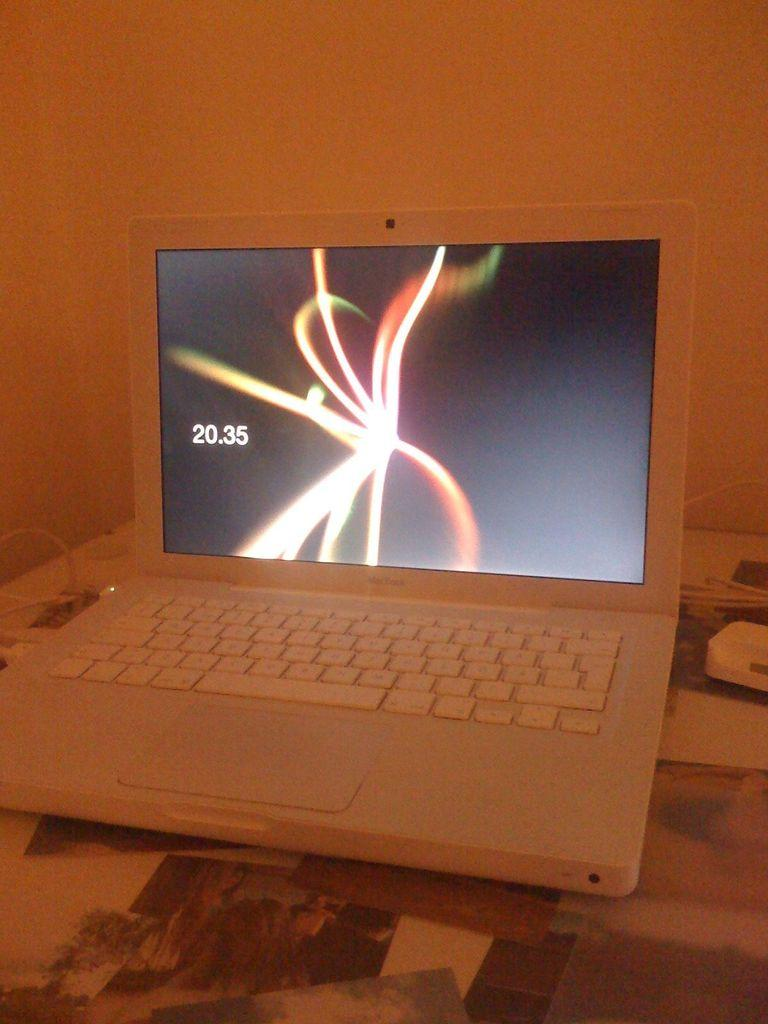<image>
Render a clear and concise summary of the photo. A white laptop with some sort of light display on the screen next to the number 20.35. 